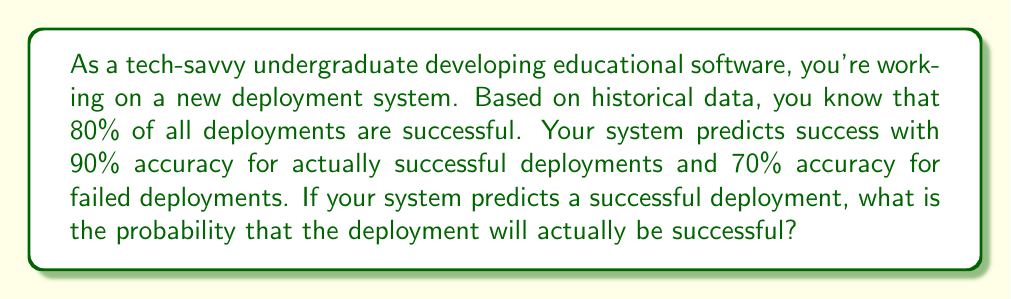Help me with this question. Let's approach this using Bayesian inference:

1. Define our events:
   S: The deployment is successful
   P: The system predicts success

2. Given information:
   P(S) = 0.80 (prior probability of success)
   P(P|S) = 0.90 (probability of predicting success given actual success)
   P(P|not S) = 0.30 (probability of predicting success given actual failure)

3. We want to find P(S|P) using Bayes' theorem:

   $$P(S|P) = \frac{P(P|S) \cdot P(S)}{P(P)}$$

4. Calculate P(P) using the law of total probability:
   
   $$P(P) = P(P|S) \cdot P(S) + P(P|not S) \cdot P(not S)$$
   $$P(P) = 0.90 \cdot 0.80 + 0.30 \cdot 0.20$$
   $$P(P) = 0.72 + 0.06 = 0.78$$

5. Now we can apply Bayes' theorem:

   $$P(S|P) = \frac{0.90 \cdot 0.80}{0.78} = \frac{0.72}{0.78} \approx 0.9231$$

6. Convert to a percentage:
   0.9231 * 100% ≈ 92.31%
Answer: 92.31% 